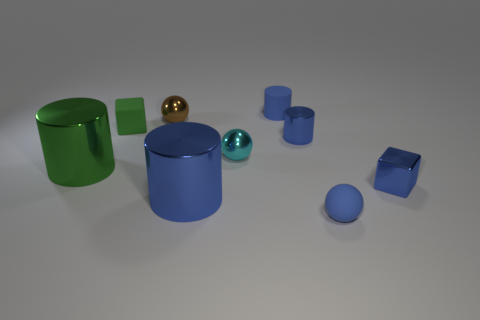How many rubber spheres have the same color as the matte cylinder?
Provide a short and direct response. 1. Is the matte cylinder the same color as the tiny matte sphere?
Your response must be concise. Yes. Is there a cyan rubber sphere?
Offer a terse response. No. What size is the green object that is in front of the tiny cube behind the small block to the right of the small rubber cylinder?
Ensure brevity in your answer.  Large. What number of other things are there of the same size as the green shiny object?
Give a very brief answer. 1. What size is the brown metal sphere left of the small metallic cube?
Provide a succinct answer. Small. Does the tiny brown object behind the green rubber thing have the same material as the blue ball?
Give a very brief answer. No. How many tiny blue shiny objects are both on the right side of the blue sphere and behind the cyan object?
Offer a terse response. 0. There is a cylinder in front of the small metallic cube on the right side of the green rubber object; what size is it?
Offer a very short reply. Large. Are there more cubes than blue cylinders?
Your response must be concise. No. 